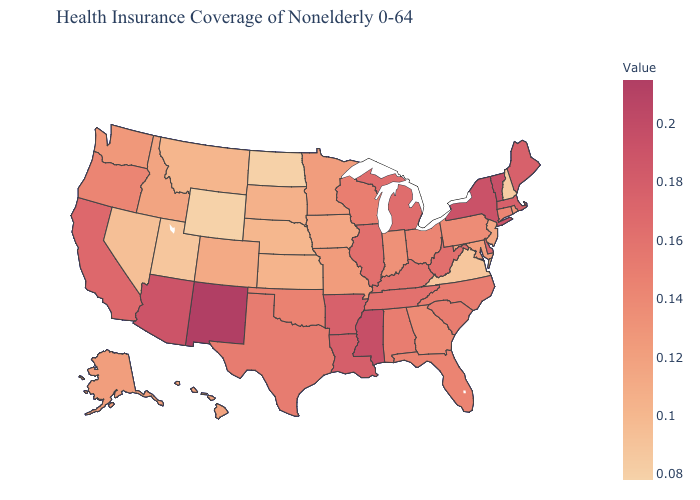Which states have the lowest value in the USA?
Answer briefly. Wyoming. Does Massachusetts have a lower value than New Mexico?
Answer briefly. Yes. Among the states that border Illinois , does Iowa have the lowest value?
Be succinct. Yes. 